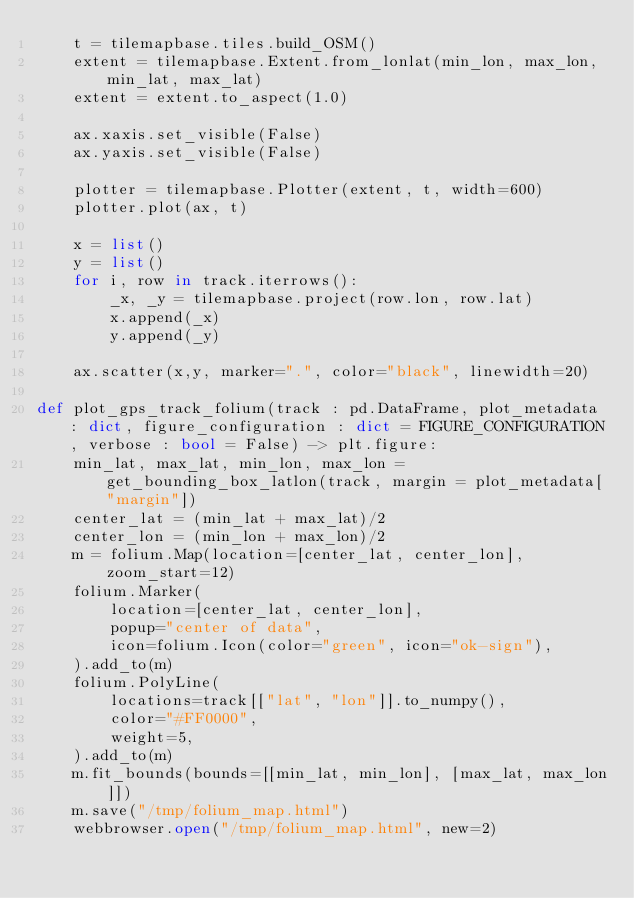Convert code to text. <code><loc_0><loc_0><loc_500><loc_500><_Python_>    t = tilemapbase.tiles.build_OSM()
    extent = tilemapbase.Extent.from_lonlat(min_lon, max_lon, min_lat, max_lat)
    extent = extent.to_aspect(1.0)

    ax.xaxis.set_visible(False)
    ax.yaxis.set_visible(False)

    plotter = tilemapbase.Plotter(extent, t, width=600)
    plotter.plot(ax, t)
   
    x = list()
    y = list()
    for i, row in track.iterrows():
        _x, _y = tilemapbase.project(row.lon, row.lat)
        x.append(_x)
        y.append(_y)

    ax.scatter(x,y, marker=".", color="black", linewidth=20)

def plot_gps_track_folium(track : pd.DataFrame, plot_metadata : dict, figure_configuration : dict = FIGURE_CONFIGURATION, verbose : bool = False) -> plt.figure:
    min_lat, max_lat, min_lon, max_lon = get_bounding_box_latlon(track, margin = plot_metadata["margin"])
    center_lat = (min_lat + max_lat)/2
    center_lon = (min_lon + max_lon)/2
    m = folium.Map(location=[center_lat, center_lon], zoom_start=12)
    folium.Marker(
        location=[center_lat, center_lon],
        popup="center of data",
        icon=folium.Icon(color="green", icon="ok-sign"),
    ).add_to(m)
    folium.PolyLine(
        locations=track[["lat", "lon"]].to_numpy(),
        color="#FF0000",
        weight=5,
    ).add_to(m)
    m.fit_bounds(bounds=[[min_lat, min_lon], [max_lat, max_lon]])
    m.save("/tmp/folium_map.html")
    webbrowser.open("/tmp/folium_map.html", new=2)

</code> 